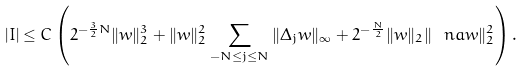<formula> <loc_0><loc_0><loc_500><loc_500>| I | \leq C \left ( 2 ^ { - \frac { 3 } { 2 } N } \| w \| _ { 2 } ^ { 3 } + \| w \| _ { 2 } ^ { 2 } \sum _ { - N \leq j \leq N } \| \Delta _ { j } w \| _ { \infty } + 2 ^ { - \frac { N } { 2 } } \| w \| _ { 2 } \| \ n a w \| _ { 2 } ^ { 2 } \right ) .</formula> 